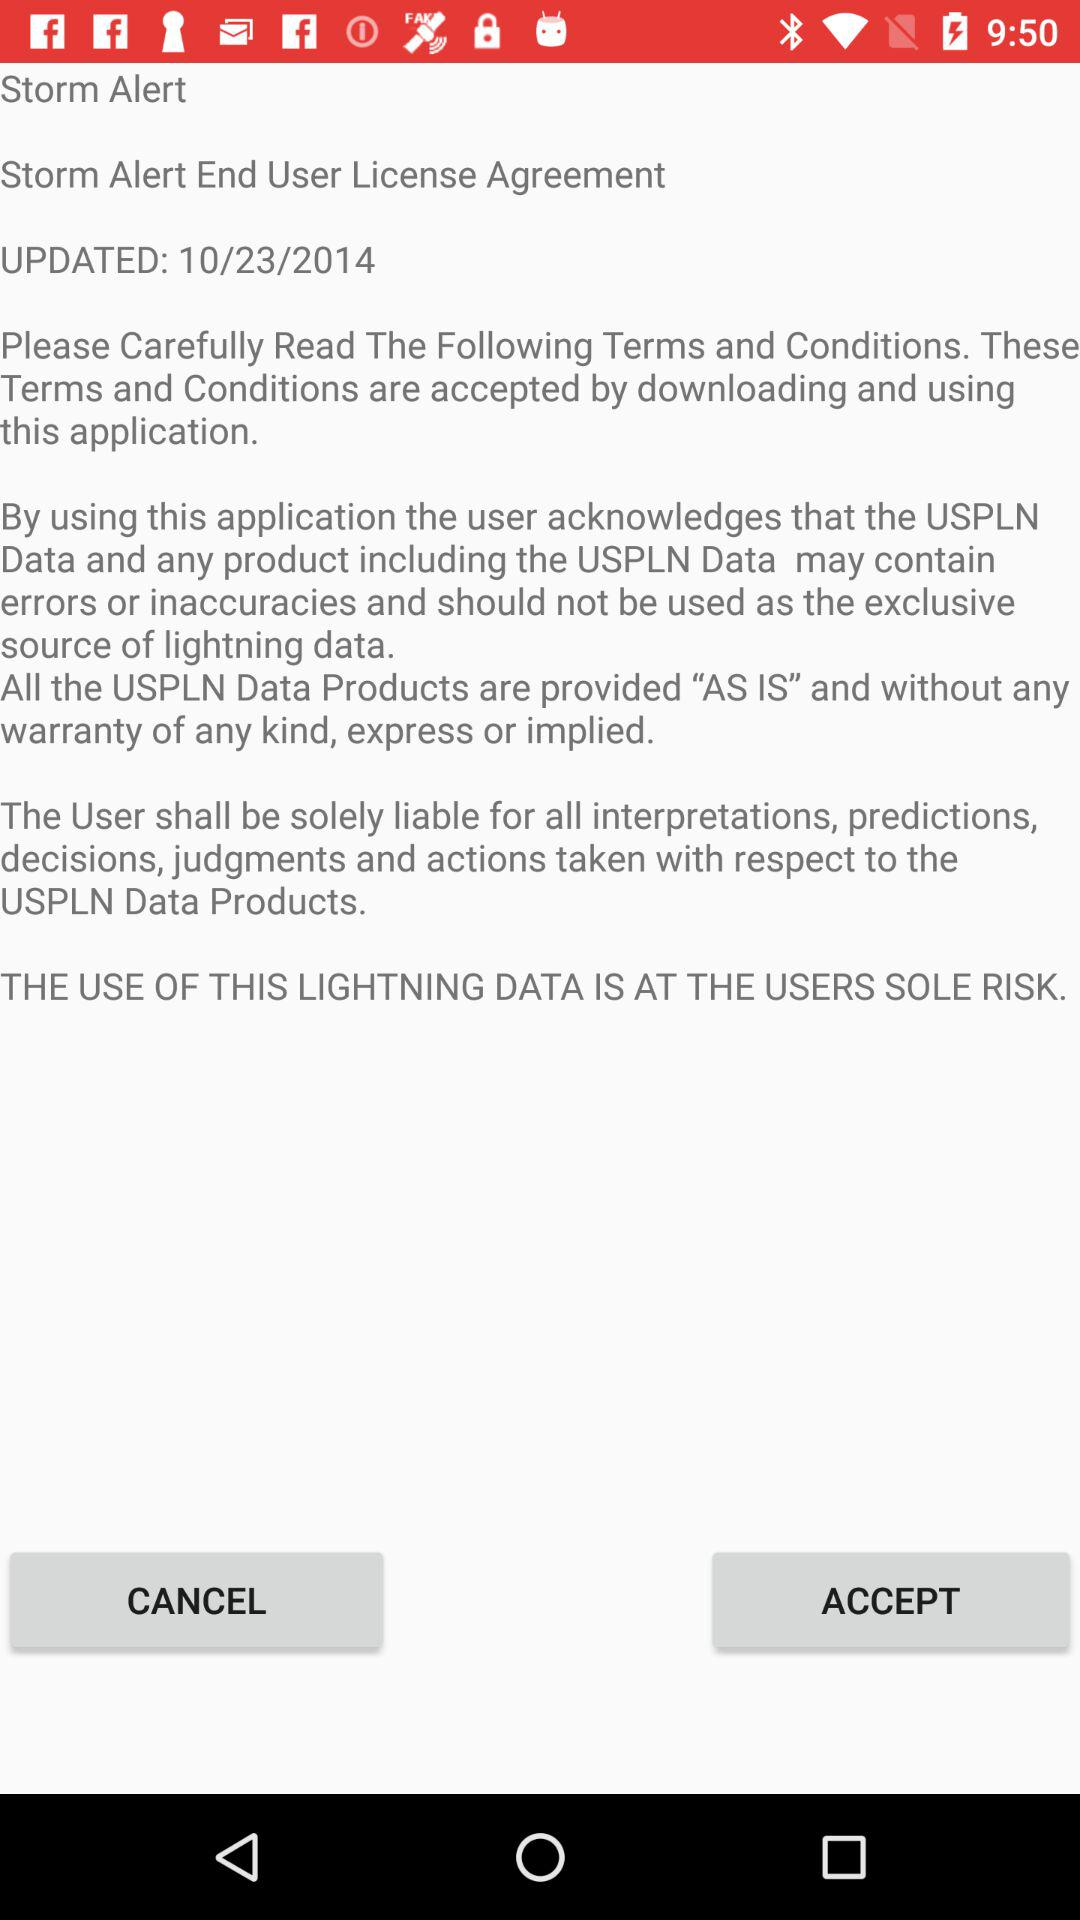When was it updated? It was updated on October 23, 2014. 